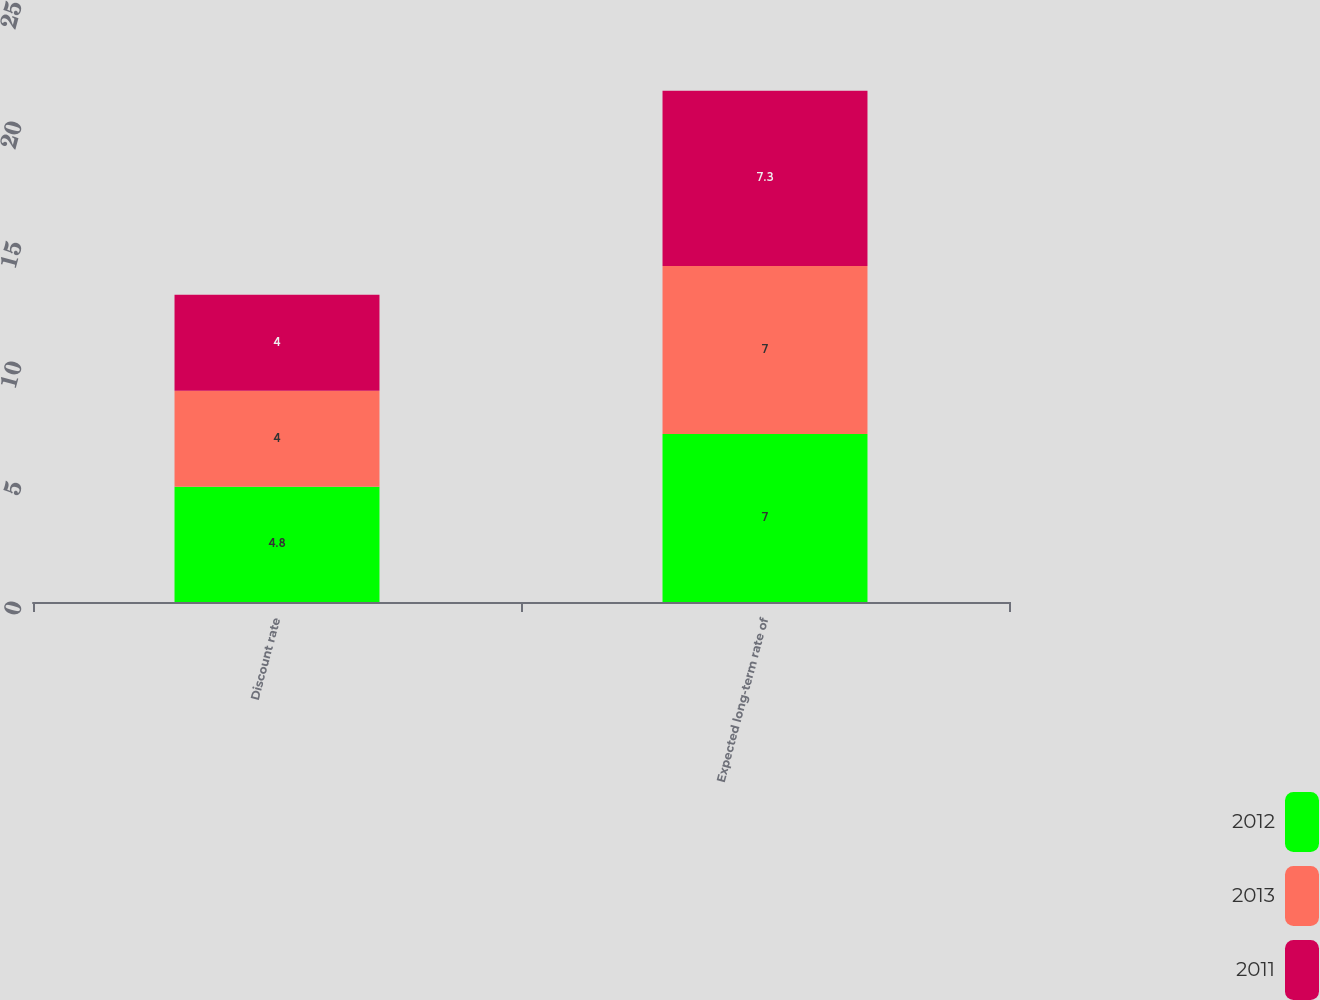Convert chart to OTSL. <chart><loc_0><loc_0><loc_500><loc_500><stacked_bar_chart><ecel><fcel>Discount rate<fcel>Expected long-term rate of<nl><fcel>2012<fcel>4.8<fcel>7<nl><fcel>2013<fcel>4<fcel>7<nl><fcel>2011<fcel>4<fcel>7.3<nl></chart> 